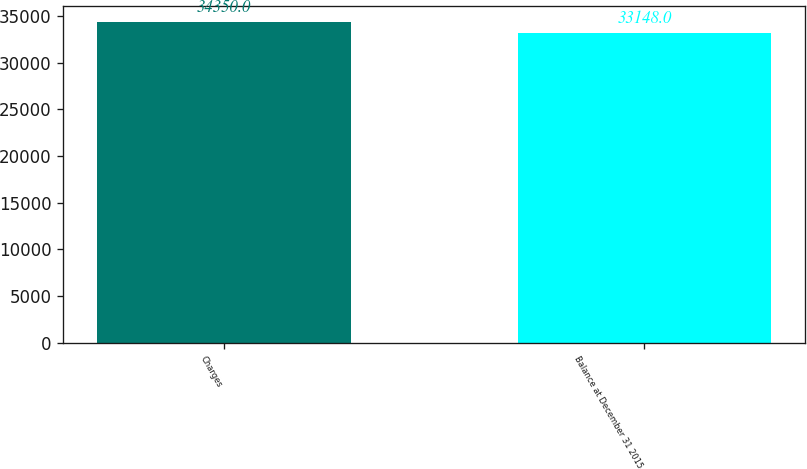<chart> <loc_0><loc_0><loc_500><loc_500><bar_chart><fcel>Charges<fcel>Balance at December 31 2015<nl><fcel>34350<fcel>33148<nl></chart> 